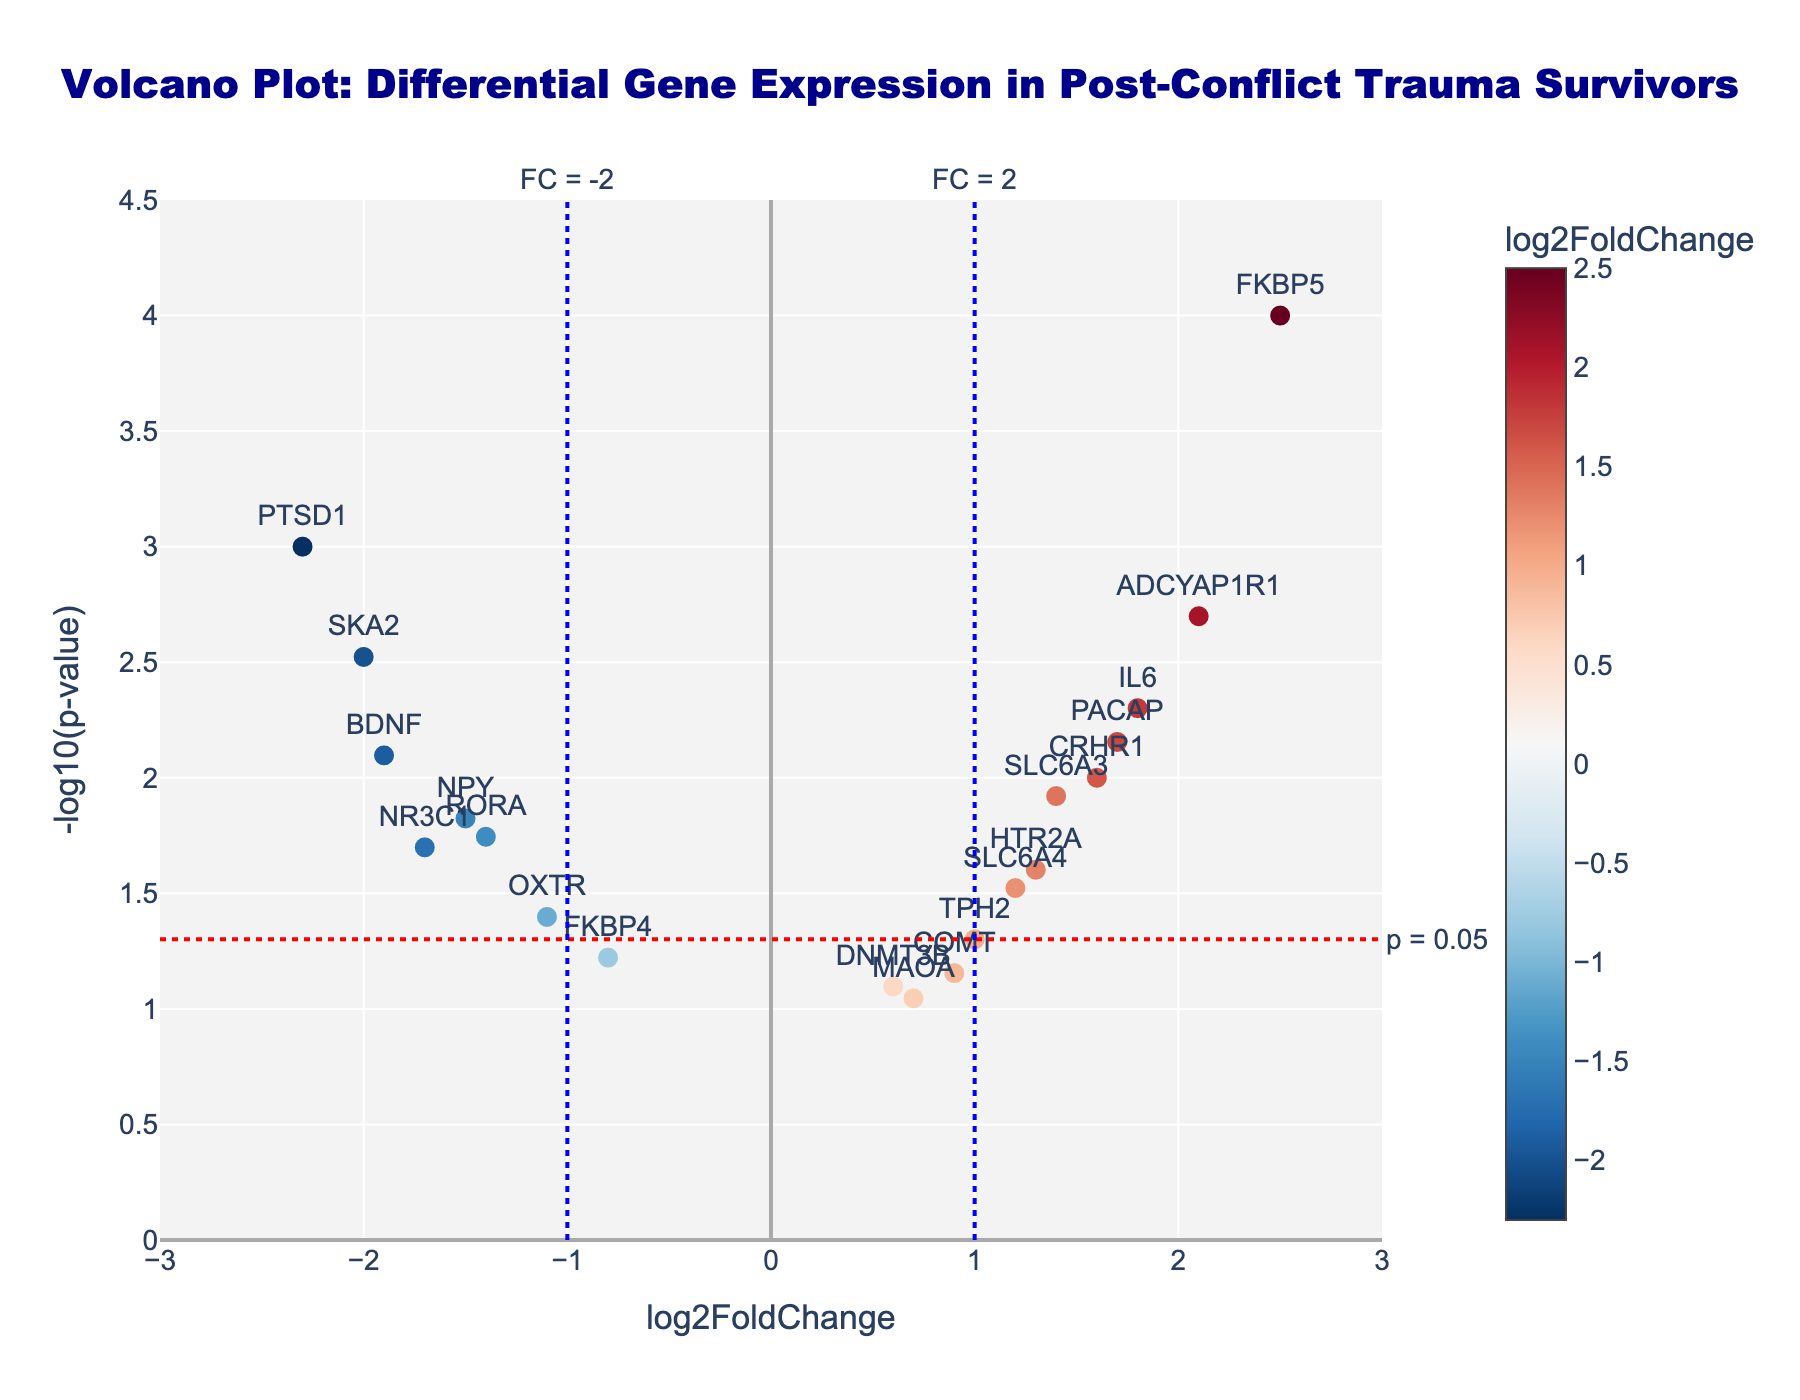What is the title of the figure? The title of the Volcano Plot is centered at the top of the figure and is written in dark blue text. It reads: "Volcano Plot: Differential Gene Expression in Post-Conflict Trauma Survivors".
Answer: Volcano Plot: Differential Gene Expression in Post-Conflict Trauma Survivors What does the x-axis represent? The label of the x-axis is located at the bottom of the figure and reads: "log2FoldChange". This indicates that the x-axis represents the log2 transformation of the fold change in gene expression.
Answer: log2FoldChange What is indicated by the colors of the points in the plot? The colors of the points represent the log2FoldChange values. There is a color scale bar on the right side of the plot, ranging from blue (negative values) to red (positive values).
Answer: The colors represent log2FoldChange values Which gene has the lowest p-value? The gene with the lowest p-value will have the highest -log10(p-value). By examining the point that is highest on the y-axis, we see the gene FKBP5.
Answer: FKBP5 How many genes have a log2FoldChange greater than 1? To answer this, we need to count the number of points to the right of the line x = 1. The genes are: FKBP5, ADCYAP1R1, and IL6, i.e., three genes.
Answer: 3 Which gene has the highest log2FoldChange value? FKBP5, located furthest to the right on the x-axis, has the largest log2FoldChange value of 2.5.
Answer: FKBP5 Which gene has both a significant p-value (p < 0.05) and is significantly down-regulated (log2FoldChange < -1)? Significant p-values convert to a -log10(p-value) greater than approximately 1.3, meaning they lie above the horizontal red line in the plot. The genes fitting this criterion are PTSD1, NR3C1, BDNF, NPY, OXTR, RORA, and SKA2.
Answer: PTSD1, NR3C1, BDNF, NPY, OXTR, RORA, SKA2 How many genes are above the significance threshold p = 0.05? The significance threshold is depicted by a horizontal red dotted line. Genes above this line have a significant p-value. Counting these, we find 13 genes.
Answer: 13 Comparing ADCYAP1R1 and SLC6A3, which gene is more significantly differentially expressed based on the log2FoldChange? ADCYAP1R1 has a log2FoldChange of 2.1, which is higher than SLC6A3's log2FoldChange of 1.4. Therefore, ADCYAP1R1 is more significantly differentially expressed.
Answer: ADCYAP1R1 Are there more up-regulated or down-regulated genes with significant p-values? Up-regulated genes have positive log2FoldChange and lie to the right of zero x-axis, while down-regulated genes lie to the left of zero x-axis. Counting the significant genes (above the horizontal line), we find 6 up-regulated and 7 down-regulated. Thus, more down-regulated genes have significant p-values.
Answer: More down-regulated genes 